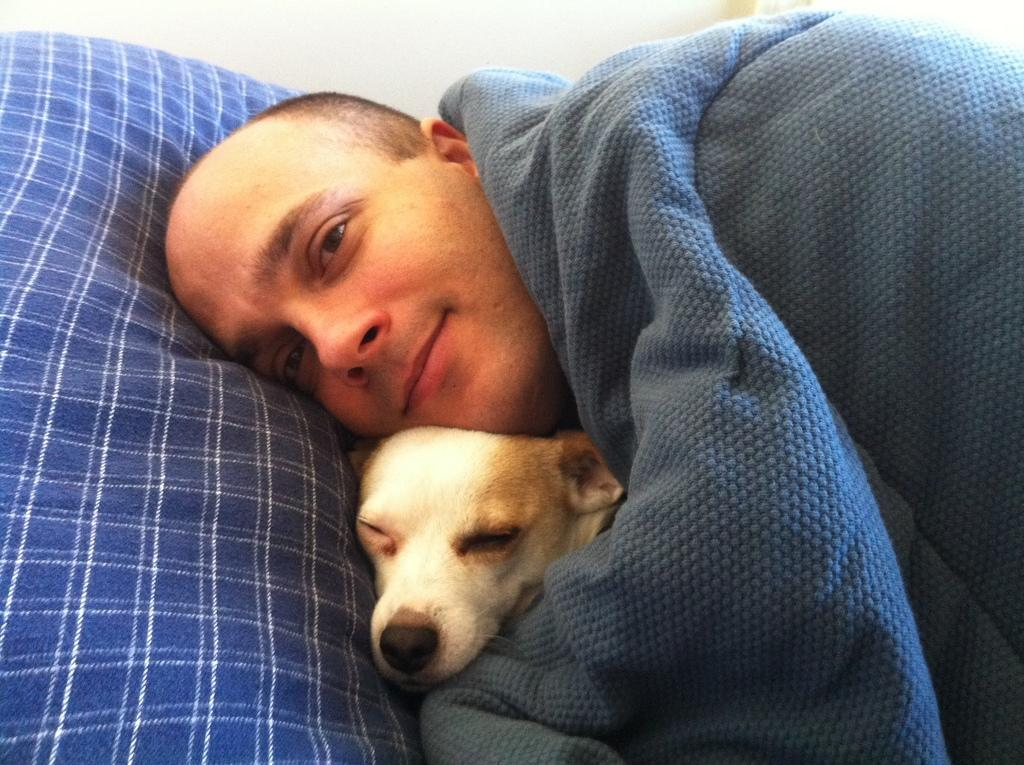Who is present in the image? There is a man in the image. What other living creature can be seen in the image? There is a dog in the image. What type of card is the man holding in the image? There is no card present in the image; it only features a man and a dog. What is the aftermath of the man's debt in the image? There is no mention of debt in the image, so it is not possible to discuss its aftermath. 